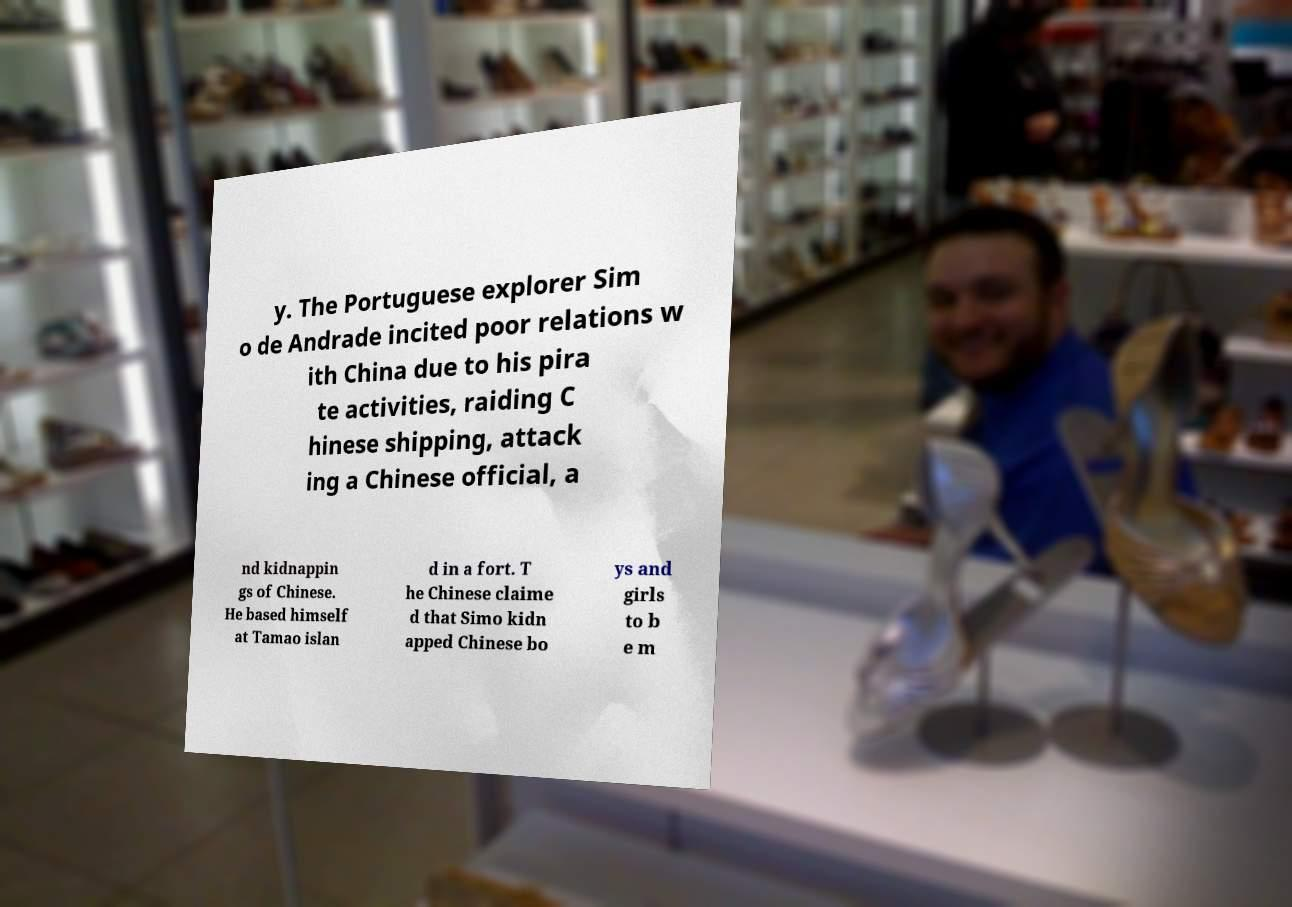Can you read and provide the text displayed in the image?This photo seems to have some interesting text. Can you extract and type it out for me? y. The Portuguese explorer Sim o de Andrade incited poor relations w ith China due to his pira te activities, raiding C hinese shipping, attack ing a Chinese official, a nd kidnappin gs of Chinese. He based himself at Tamao islan d in a fort. T he Chinese claime d that Simo kidn apped Chinese bo ys and girls to b e m 